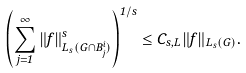<formula> <loc_0><loc_0><loc_500><loc_500>\left ( \sum _ { j = 1 } ^ { \infty } \| f \| _ { L _ { s } ( G \cap B _ { j } ^ { i } ) } ^ { s } \right ) ^ { 1 / s } \leq C _ { s , L } \| f \| _ { L _ { s } ( G ) } .</formula> 